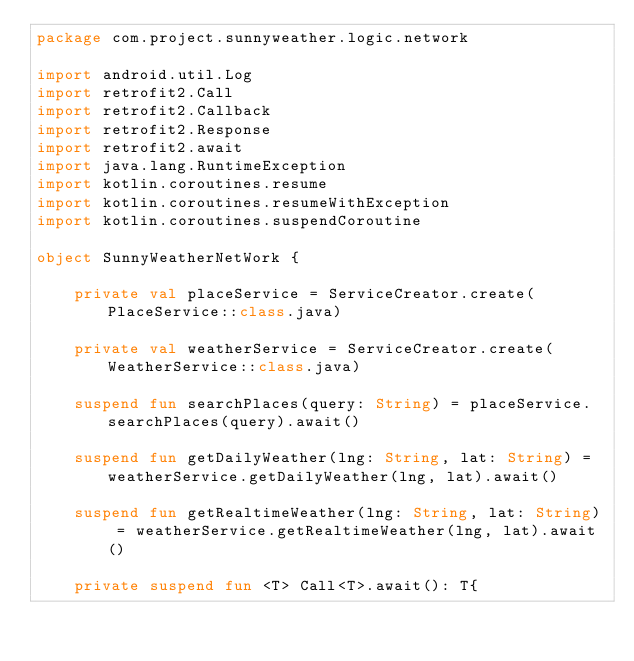<code> <loc_0><loc_0><loc_500><loc_500><_Kotlin_>package com.project.sunnyweather.logic.network

import android.util.Log
import retrofit2.Call
import retrofit2.Callback
import retrofit2.Response
import retrofit2.await
import java.lang.RuntimeException
import kotlin.coroutines.resume
import kotlin.coroutines.resumeWithException
import kotlin.coroutines.suspendCoroutine

object SunnyWeatherNetWork {

    private val placeService = ServiceCreator.create(PlaceService::class.java)

    private val weatherService = ServiceCreator.create(WeatherService::class.java)

    suspend fun searchPlaces(query: String) = placeService.searchPlaces(query).await()

    suspend fun getDailyWeather(lng: String, lat: String) = weatherService.getDailyWeather(lng, lat).await()

    suspend fun getRealtimeWeather(lng: String, lat: String) = weatherService.getRealtimeWeather(lng, lat).await()

    private suspend fun <T> Call<T>.await(): T{</code> 